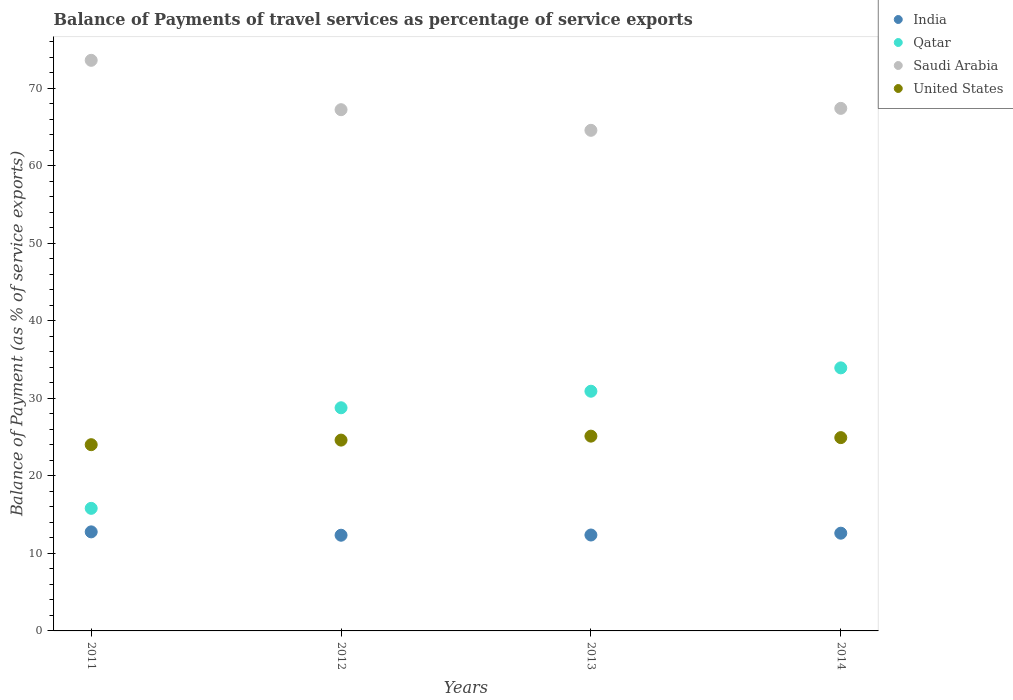How many different coloured dotlines are there?
Provide a short and direct response. 4. Is the number of dotlines equal to the number of legend labels?
Your answer should be very brief. Yes. What is the balance of payments of travel services in Qatar in 2012?
Provide a short and direct response. 28.8. Across all years, what is the maximum balance of payments of travel services in United States?
Make the answer very short. 25.13. Across all years, what is the minimum balance of payments of travel services in Saudi Arabia?
Keep it short and to the point. 64.6. What is the total balance of payments of travel services in United States in the graph?
Offer a very short reply. 98.73. What is the difference between the balance of payments of travel services in Saudi Arabia in 2011 and that in 2014?
Offer a very short reply. 6.2. What is the difference between the balance of payments of travel services in Qatar in 2013 and the balance of payments of travel services in Saudi Arabia in 2014?
Offer a terse response. -36.5. What is the average balance of payments of travel services in Qatar per year?
Ensure brevity in your answer.  27.37. In the year 2014, what is the difference between the balance of payments of travel services in Qatar and balance of payments of travel services in Saudi Arabia?
Ensure brevity in your answer.  -33.49. In how many years, is the balance of payments of travel services in Saudi Arabia greater than 12 %?
Keep it short and to the point. 4. What is the ratio of the balance of payments of travel services in India in 2011 to that in 2012?
Your answer should be very brief. 1.04. Is the difference between the balance of payments of travel services in Qatar in 2013 and 2014 greater than the difference between the balance of payments of travel services in Saudi Arabia in 2013 and 2014?
Make the answer very short. No. What is the difference between the highest and the second highest balance of payments of travel services in India?
Give a very brief answer. 0.17. What is the difference between the highest and the lowest balance of payments of travel services in United States?
Provide a succinct answer. 1.1. Is it the case that in every year, the sum of the balance of payments of travel services in United States and balance of payments of travel services in Saudi Arabia  is greater than the balance of payments of travel services in India?
Keep it short and to the point. Yes. How many years are there in the graph?
Provide a succinct answer. 4. What is the difference between two consecutive major ticks on the Y-axis?
Your answer should be very brief. 10. Does the graph contain any zero values?
Make the answer very short. No. What is the title of the graph?
Make the answer very short. Balance of Payments of travel services as percentage of service exports. Does "Uzbekistan" appear as one of the legend labels in the graph?
Give a very brief answer. No. What is the label or title of the X-axis?
Provide a short and direct response. Years. What is the label or title of the Y-axis?
Offer a very short reply. Balance of Payment (as % of service exports). What is the Balance of Payment (as % of service exports) of India in 2011?
Provide a succinct answer. 12.78. What is the Balance of Payment (as % of service exports) in Qatar in 2011?
Offer a terse response. 15.82. What is the Balance of Payment (as % of service exports) of Saudi Arabia in 2011?
Keep it short and to the point. 73.63. What is the Balance of Payment (as % of service exports) in United States in 2011?
Offer a very short reply. 24.03. What is the Balance of Payment (as % of service exports) in India in 2012?
Your response must be concise. 12.35. What is the Balance of Payment (as % of service exports) of Qatar in 2012?
Your answer should be compact. 28.8. What is the Balance of Payment (as % of service exports) in Saudi Arabia in 2012?
Your answer should be compact. 67.26. What is the Balance of Payment (as % of service exports) in United States in 2012?
Offer a very short reply. 24.62. What is the Balance of Payment (as % of service exports) in India in 2013?
Give a very brief answer. 12.38. What is the Balance of Payment (as % of service exports) in Qatar in 2013?
Your answer should be compact. 30.93. What is the Balance of Payment (as % of service exports) in Saudi Arabia in 2013?
Make the answer very short. 64.6. What is the Balance of Payment (as % of service exports) in United States in 2013?
Your answer should be compact. 25.13. What is the Balance of Payment (as % of service exports) in India in 2014?
Provide a succinct answer. 12.61. What is the Balance of Payment (as % of service exports) in Qatar in 2014?
Your answer should be compact. 33.94. What is the Balance of Payment (as % of service exports) of Saudi Arabia in 2014?
Ensure brevity in your answer.  67.43. What is the Balance of Payment (as % of service exports) of United States in 2014?
Provide a succinct answer. 24.94. Across all years, what is the maximum Balance of Payment (as % of service exports) in India?
Your response must be concise. 12.78. Across all years, what is the maximum Balance of Payment (as % of service exports) of Qatar?
Offer a very short reply. 33.94. Across all years, what is the maximum Balance of Payment (as % of service exports) in Saudi Arabia?
Your answer should be compact. 73.63. Across all years, what is the maximum Balance of Payment (as % of service exports) of United States?
Offer a very short reply. 25.13. Across all years, what is the minimum Balance of Payment (as % of service exports) in India?
Your response must be concise. 12.35. Across all years, what is the minimum Balance of Payment (as % of service exports) in Qatar?
Ensure brevity in your answer.  15.82. Across all years, what is the minimum Balance of Payment (as % of service exports) in Saudi Arabia?
Offer a terse response. 64.6. Across all years, what is the minimum Balance of Payment (as % of service exports) in United States?
Keep it short and to the point. 24.03. What is the total Balance of Payment (as % of service exports) in India in the graph?
Offer a very short reply. 50.12. What is the total Balance of Payment (as % of service exports) of Qatar in the graph?
Your answer should be compact. 109.49. What is the total Balance of Payment (as % of service exports) of Saudi Arabia in the graph?
Give a very brief answer. 272.92. What is the total Balance of Payment (as % of service exports) of United States in the graph?
Keep it short and to the point. 98.73. What is the difference between the Balance of Payment (as % of service exports) of India in 2011 and that in 2012?
Provide a short and direct response. 0.43. What is the difference between the Balance of Payment (as % of service exports) in Qatar in 2011 and that in 2012?
Provide a succinct answer. -12.98. What is the difference between the Balance of Payment (as % of service exports) in Saudi Arabia in 2011 and that in 2012?
Provide a short and direct response. 6.37. What is the difference between the Balance of Payment (as % of service exports) in United States in 2011 and that in 2012?
Your answer should be compact. -0.59. What is the difference between the Balance of Payment (as % of service exports) of India in 2011 and that in 2013?
Your answer should be very brief. 0.41. What is the difference between the Balance of Payment (as % of service exports) of Qatar in 2011 and that in 2013?
Your answer should be compact. -15.11. What is the difference between the Balance of Payment (as % of service exports) in Saudi Arabia in 2011 and that in 2013?
Provide a short and direct response. 9.03. What is the difference between the Balance of Payment (as % of service exports) of United States in 2011 and that in 2013?
Give a very brief answer. -1.1. What is the difference between the Balance of Payment (as % of service exports) of India in 2011 and that in 2014?
Provide a succinct answer. 0.17. What is the difference between the Balance of Payment (as % of service exports) in Qatar in 2011 and that in 2014?
Make the answer very short. -18.13. What is the difference between the Balance of Payment (as % of service exports) in Saudi Arabia in 2011 and that in 2014?
Keep it short and to the point. 6.2. What is the difference between the Balance of Payment (as % of service exports) in United States in 2011 and that in 2014?
Offer a very short reply. -0.91. What is the difference between the Balance of Payment (as % of service exports) of India in 2012 and that in 2013?
Provide a succinct answer. -0.03. What is the difference between the Balance of Payment (as % of service exports) of Qatar in 2012 and that in 2013?
Your response must be concise. -2.14. What is the difference between the Balance of Payment (as % of service exports) of Saudi Arabia in 2012 and that in 2013?
Your answer should be very brief. 2.66. What is the difference between the Balance of Payment (as % of service exports) of United States in 2012 and that in 2013?
Make the answer very short. -0.51. What is the difference between the Balance of Payment (as % of service exports) in India in 2012 and that in 2014?
Keep it short and to the point. -0.26. What is the difference between the Balance of Payment (as % of service exports) in Qatar in 2012 and that in 2014?
Make the answer very short. -5.15. What is the difference between the Balance of Payment (as % of service exports) in Saudi Arabia in 2012 and that in 2014?
Your answer should be compact. -0.17. What is the difference between the Balance of Payment (as % of service exports) of United States in 2012 and that in 2014?
Give a very brief answer. -0.32. What is the difference between the Balance of Payment (as % of service exports) in India in 2013 and that in 2014?
Your response must be concise. -0.24. What is the difference between the Balance of Payment (as % of service exports) in Qatar in 2013 and that in 2014?
Your answer should be compact. -3.01. What is the difference between the Balance of Payment (as % of service exports) of Saudi Arabia in 2013 and that in 2014?
Your answer should be compact. -2.83. What is the difference between the Balance of Payment (as % of service exports) in United States in 2013 and that in 2014?
Your answer should be compact. 0.19. What is the difference between the Balance of Payment (as % of service exports) in India in 2011 and the Balance of Payment (as % of service exports) in Qatar in 2012?
Make the answer very short. -16.01. What is the difference between the Balance of Payment (as % of service exports) of India in 2011 and the Balance of Payment (as % of service exports) of Saudi Arabia in 2012?
Make the answer very short. -54.48. What is the difference between the Balance of Payment (as % of service exports) of India in 2011 and the Balance of Payment (as % of service exports) of United States in 2012?
Offer a terse response. -11.84. What is the difference between the Balance of Payment (as % of service exports) in Qatar in 2011 and the Balance of Payment (as % of service exports) in Saudi Arabia in 2012?
Offer a very short reply. -51.44. What is the difference between the Balance of Payment (as % of service exports) in Qatar in 2011 and the Balance of Payment (as % of service exports) in United States in 2012?
Provide a succinct answer. -8.81. What is the difference between the Balance of Payment (as % of service exports) in Saudi Arabia in 2011 and the Balance of Payment (as % of service exports) in United States in 2012?
Your response must be concise. 49.01. What is the difference between the Balance of Payment (as % of service exports) in India in 2011 and the Balance of Payment (as % of service exports) in Qatar in 2013?
Give a very brief answer. -18.15. What is the difference between the Balance of Payment (as % of service exports) in India in 2011 and the Balance of Payment (as % of service exports) in Saudi Arabia in 2013?
Ensure brevity in your answer.  -51.82. What is the difference between the Balance of Payment (as % of service exports) of India in 2011 and the Balance of Payment (as % of service exports) of United States in 2013?
Give a very brief answer. -12.35. What is the difference between the Balance of Payment (as % of service exports) in Qatar in 2011 and the Balance of Payment (as % of service exports) in Saudi Arabia in 2013?
Provide a short and direct response. -48.78. What is the difference between the Balance of Payment (as % of service exports) in Qatar in 2011 and the Balance of Payment (as % of service exports) in United States in 2013?
Your response must be concise. -9.32. What is the difference between the Balance of Payment (as % of service exports) in Saudi Arabia in 2011 and the Balance of Payment (as % of service exports) in United States in 2013?
Your answer should be very brief. 48.5. What is the difference between the Balance of Payment (as % of service exports) in India in 2011 and the Balance of Payment (as % of service exports) in Qatar in 2014?
Offer a terse response. -21.16. What is the difference between the Balance of Payment (as % of service exports) in India in 2011 and the Balance of Payment (as % of service exports) in Saudi Arabia in 2014?
Keep it short and to the point. -54.65. What is the difference between the Balance of Payment (as % of service exports) in India in 2011 and the Balance of Payment (as % of service exports) in United States in 2014?
Give a very brief answer. -12.16. What is the difference between the Balance of Payment (as % of service exports) in Qatar in 2011 and the Balance of Payment (as % of service exports) in Saudi Arabia in 2014?
Your answer should be very brief. -51.61. What is the difference between the Balance of Payment (as % of service exports) in Qatar in 2011 and the Balance of Payment (as % of service exports) in United States in 2014?
Give a very brief answer. -9.13. What is the difference between the Balance of Payment (as % of service exports) of Saudi Arabia in 2011 and the Balance of Payment (as % of service exports) of United States in 2014?
Keep it short and to the point. 48.69. What is the difference between the Balance of Payment (as % of service exports) in India in 2012 and the Balance of Payment (as % of service exports) in Qatar in 2013?
Offer a terse response. -18.58. What is the difference between the Balance of Payment (as % of service exports) of India in 2012 and the Balance of Payment (as % of service exports) of Saudi Arabia in 2013?
Offer a terse response. -52.25. What is the difference between the Balance of Payment (as % of service exports) in India in 2012 and the Balance of Payment (as % of service exports) in United States in 2013?
Your answer should be compact. -12.79. What is the difference between the Balance of Payment (as % of service exports) of Qatar in 2012 and the Balance of Payment (as % of service exports) of Saudi Arabia in 2013?
Your response must be concise. -35.8. What is the difference between the Balance of Payment (as % of service exports) in Qatar in 2012 and the Balance of Payment (as % of service exports) in United States in 2013?
Give a very brief answer. 3.66. What is the difference between the Balance of Payment (as % of service exports) in Saudi Arabia in 2012 and the Balance of Payment (as % of service exports) in United States in 2013?
Give a very brief answer. 42.13. What is the difference between the Balance of Payment (as % of service exports) in India in 2012 and the Balance of Payment (as % of service exports) in Qatar in 2014?
Offer a very short reply. -21.6. What is the difference between the Balance of Payment (as % of service exports) in India in 2012 and the Balance of Payment (as % of service exports) in Saudi Arabia in 2014?
Your answer should be very brief. -55.08. What is the difference between the Balance of Payment (as % of service exports) of India in 2012 and the Balance of Payment (as % of service exports) of United States in 2014?
Provide a succinct answer. -12.59. What is the difference between the Balance of Payment (as % of service exports) in Qatar in 2012 and the Balance of Payment (as % of service exports) in Saudi Arabia in 2014?
Your response must be concise. -38.64. What is the difference between the Balance of Payment (as % of service exports) in Qatar in 2012 and the Balance of Payment (as % of service exports) in United States in 2014?
Provide a succinct answer. 3.85. What is the difference between the Balance of Payment (as % of service exports) of Saudi Arabia in 2012 and the Balance of Payment (as % of service exports) of United States in 2014?
Make the answer very short. 42.32. What is the difference between the Balance of Payment (as % of service exports) of India in 2013 and the Balance of Payment (as % of service exports) of Qatar in 2014?
Provide a succinct answer. -21.57. What is the difference between the Balance of Payment (as % of service exports) in India in 2013 and the Balance of Payment (as % of service exports) in Saudi Arabia in 2014?
Offer a terse response. -55.06. What is the difference between the Balance of Payment (as % of service exports) in India in 2013 and the Balance of Payment (as % of service exports) in United States in 2014?
Provide a succinct answer. -12.57. What is the difference between the Balance of Payment (as % of service exports) in Qatar in 2013 and the Balance of Payment (as % of service exports) in Saudi Arabia in 2014?
Offer a terse response. -36.5. What is the difference between the Balance of Payment (as % of service exports) of Qatar in 2013 and the Balance of Payment (as % of service exports) of United States in 2014?
Keep it short and to the point. 5.99. What is the difference between the Balance of Payment (as % of service exports) of Saudi Arabia in 2013 and the Balance of Payment (as % of service exports) of United States in 2014?
Your response must be concise. 39.65. What is the average Balance of Payment (as % of service exports) of India per year?
Offer a terse response. 12.53. What is the average Balance of Payment (as % of service exports) in Qatar per year?
Provide a succinct answer. 27.37. What is the average Balance of Payment (as % of service exports) of Saudi Arabia per year?
Your answer should be compact. 68.23. What is the average Balance of Payment (as % of service exports) of United States per year?
Make the answer very short. 24.68. In the year 2011, what is the difference between the Balance of Payment (as % of service exports) in India and Balance of Payment (as % of service exports) in Qatar?
Make the answer very short. -3.04. In the year 2011, what is the difference between the Balance of Payment (as % of service exports) of India and Balance of Payment (as % of service exports) of Saudi Arabia?
Your answer should be compact. -60.85. In the year 2011, what is the difference between the Balance of Payment (as % of service exports) of India and Balance of Payment (as % of service exports) of United States?
Your answer should be very brief. -11.25. In the year 2011, what is the difference between the Balance of Payment (as % of service exports) in Qatar and Balance of Payment (as % of service exports) in Saudi Arabia?
Your response must be concise. -57.81. In the year 2011, what is the difference between the Balance of Payment (as % of service exports) of Qatar and Balance of Payment (as % of service exports) of United States?
Your response must be concise. -8.21. In the year 2011, what is the difference between the Balance of Payment (as % of service exports) of Saudi Arabia and Balance of Payment (as % of service exports) of United States?
Keep it short and to the point. 49.6. In the year 2012, what is the difference between the Balance of Payment (as % of service exports) of India and Balance of Payment (as % of service exports) of Qatar?
Give a very brief answer. -16.45. In the year 2012, what is the difference between the Balance of Payment (as % of service exports) in India and Balance of Payment (as % of service exports) in Saudi Arabia?
Your answer should be very brief. -54.91. In the year 2012, what is the difference between the Balance of Payment (as % of service exports) of India and Balance of Payment (as % of service exports) of United States?
Your response must be concise. -12.27. In the year 2012, what is the difference between the Balance of Payment (as % of service exports) in Qatar and Balance of Payment (as % of service exports) in Saudi Arabia?
Make the answer very short. -38.47. In the year 2012, what is the difference between the Balance of Payment (as % of service exports) of Qatar and Balance of Payment (as % of service exports) of United States?
Keep it short and to the point. 4.17. In the year 2012, what is the difference between the Balance of Payment (as % of service exports) in Saudi Arabia and Balance of Payment (as % of service exports) in United States?
Ensure brevity in your answer.  42.64. In the year 2013, what is the difference between the Balance of Payment (as % of service exports) in India and Balance of Payment (as % of service exports) in Qatar?
Your response must be concise. -18.55. In the year 2013, what is the difference between the Balance of Payment (as % of service exports) in India and Balance of Payment (as % of service exports) in Saudi Arabia?
Provide a short and direct response. -52.22. In the year 2013, what is the difference between the Balance of Payment (as % of service exports) of India and Balance of Payment (as % of service exports) of United States?
Give a very brief answer. -12.76. In the year 2013, what is the difference between the Balance of Payment (as % of service exports) in Qatar and Balance of Payment (as % of service exports) in Saudi Arabia?
Your answer should be compact. -33.67. In the year 2013, what is the difference between the Balance of Payment (as % of service exports) in Qatar and Balance of Payment (as % of service exports) in United States?
Ensure brevity in your answer.  5.8. In the year 2013, what is the difference between the Balance of Payment (as % of service exports) in Saudi Arabia and Balance of Payment (as % of service exports) in United States?
Your response must be concise. 39.46. In the year 2014, what is the difference between the Balance of Payment (as % of service exports) in India and Balance of Payment (as % of service exports) in Qatar?
Offer a very short reply. -21.33. In the year 2014, what is the difference between the Balance of Payment (as % of service exports) of India and Balance of Payment (as % of service exports) of Saudi Arabia?
Your response must be concise. -54.82. In the year 2014, what is the difference between the Balance of Payment (as % of service exports) in India and Balance of Payment (as % of service exports) in United States?
Provide a succinct answer. -12.33. In the year 2014, what is the difference between the Balance of Payment (as % of service exports) in Qatar and Balance of Payment (as % of service exports) in Saudi Arabia?
Give a very brief answer. -33.49. In the year 2014, what is the difference between the Balance of Payment (as % of service exports) in Qatar and Balance of Payment (as % of service exports) in United States?
Provide a succinct answer. 9. In the year 2014, what is the difference between the Balance of Payment (as % of service exports) of Saudi Arabia and Balance of Payment (as % of service exports) of United States?
Ensure brevity in your answer.  42.49. What is the ratio of the Balance of Payment (as % of service exports) of India in 2011 to that in 2012?
Give a very brief answer. 1.04. What is the ratio of the Balance of Payment (as % of service exports) of Qatar in 2011 to that in 2012?
Your response must be concise. 0.55. What is the ratio of the Balance of Payment (as % of service exports) of Saudi Arabia in 2011 to that in 2012?
Your answer should be compact. 1.09. What is the ratio of the Balance of Payment (as % of service exports) in India in 2011 to that in 2013?
Your answer should be very brief. 1.03. What is the ratio of the Balance of Payment (as % of service exports) of Qatar in 2011 to that in 2013?
Offer a very short reply. 0.51. What is the ratio of the Balance of Payment (as % of service exports) of Saudi Arabia in 2011 to that in 2013?
Your answer should be very brief. 1.14. What is the ratio of the Balance of Payment (as % of service exports) of United States in 2011 to that in 2013?
Provide a short and direct response. 0.96. What is the ratio of the Balance of Payment (as % of service exports) of India in 2011 to that in 2014?
Make the answer very short. 1.01. What is the ratio of the Balance of Payment (as % of service exports) in Qatar in 2011 to that in 2014?
Make the answer very short. 0.47. What is the ratio of the Balance of Payment (as % of service exports) of Saudi Arabia in 2011 to that in 2014?
Keep it short and to the point. 1.09. What is the ratio of the Balance of Payment (as % of service exports) of United States in 2011 to that in 2014?
Provide a succinct answer. 0.96. What is the ratio of the Balance of Payment (as % of service exports) of India in 2012 to that in 2013?
Keep it short and to the point. 1. What is the ratio of the Balance of Payment (as % of service exports) in Qatar in 2012 to that in 2013?
Keep it short and to the point. 0.93. What is the ratio of the Balance of Payment (as % of service exports) of Saudi Arabia in 2012 to that in 2013?
Provide a succinct answer. 1.04. What is the ratio of the Balance of Payment (as % of service exports) of United States in 2012 to that in 2013?
Provide a succinct answer. 0.98. What is the ratio of the Balance of Payment (as % of service exports) of India in 2012 to that in 2014?
Your answer should be compact. 0.98. What is the ratio of the Balance of Payment (as % of service exports) in Qatar in 2012 to that in 2014?
Provide a short and direct response. 0.85. What is the ratio of the Balance of Payment (as % of service exports) in Saudi Arabia in 2012 to that in 2014?
Offer a terse response. 1. What is the ratio of the Balance of Payment (as % of service exports) in United States in 2012 to that in 2014?
Give a very brief answer. 0.99. What is the ratio of the Balance of Payment (as % of service exports) in India in 2013 to that in 2014?
Your answer should be very brief. 0.98. What is the ratio of the Balance of Payment (as % of service exports) in Qatar in 2013 to that in 2014?
Offer a very short reply. 0.91. What is the ratio of the Balance of Payment (as % of service exports) in Saudi Arabia in 2013 to that in 2014?
Provide a short and direct response. 0.96. What is the ratio of the Balance of Payment (as % of service exports) of United States in 2013 to that in 2014?
Your response must be concise. 1.01. What is the difference between the highest and the second highest Balance of Payment (as % of service exports) in India?
Your answer should be compact. 0.17. What is the difference between the highest and the second highest Balance of Payment (as % of service exports) in Qatar?
Ensure brevity in your answer.  3.01. What is the difference between the highest and the second highest Balance of Payment (as % of service exports) in Saudi Arabia?
Make the answer very short. 6.2. What is the difference between the highest and the second highest Balance of Payment (as % of service exports) in United States?
Your answer should be very brief. 0.19. What is the difference between the highest and the lowest Balance of Payment (as % of service exports) of India?
Keep it short and to the point. 0.43. What is the difference between the highest and the lowest Balance of Payment (as % of service exports) in Qatar?
Provide a succinct answer. 18.13. What is the difference between the highest and the lowest Balance of Payment (as % of service exports) in Saudi Arabia?
Your answer should be compact. 9.03. What is the difference between the highest and the lowest Balance of Payment (as % of service exports) in United States?
Give a very brief answer. 1.1. 